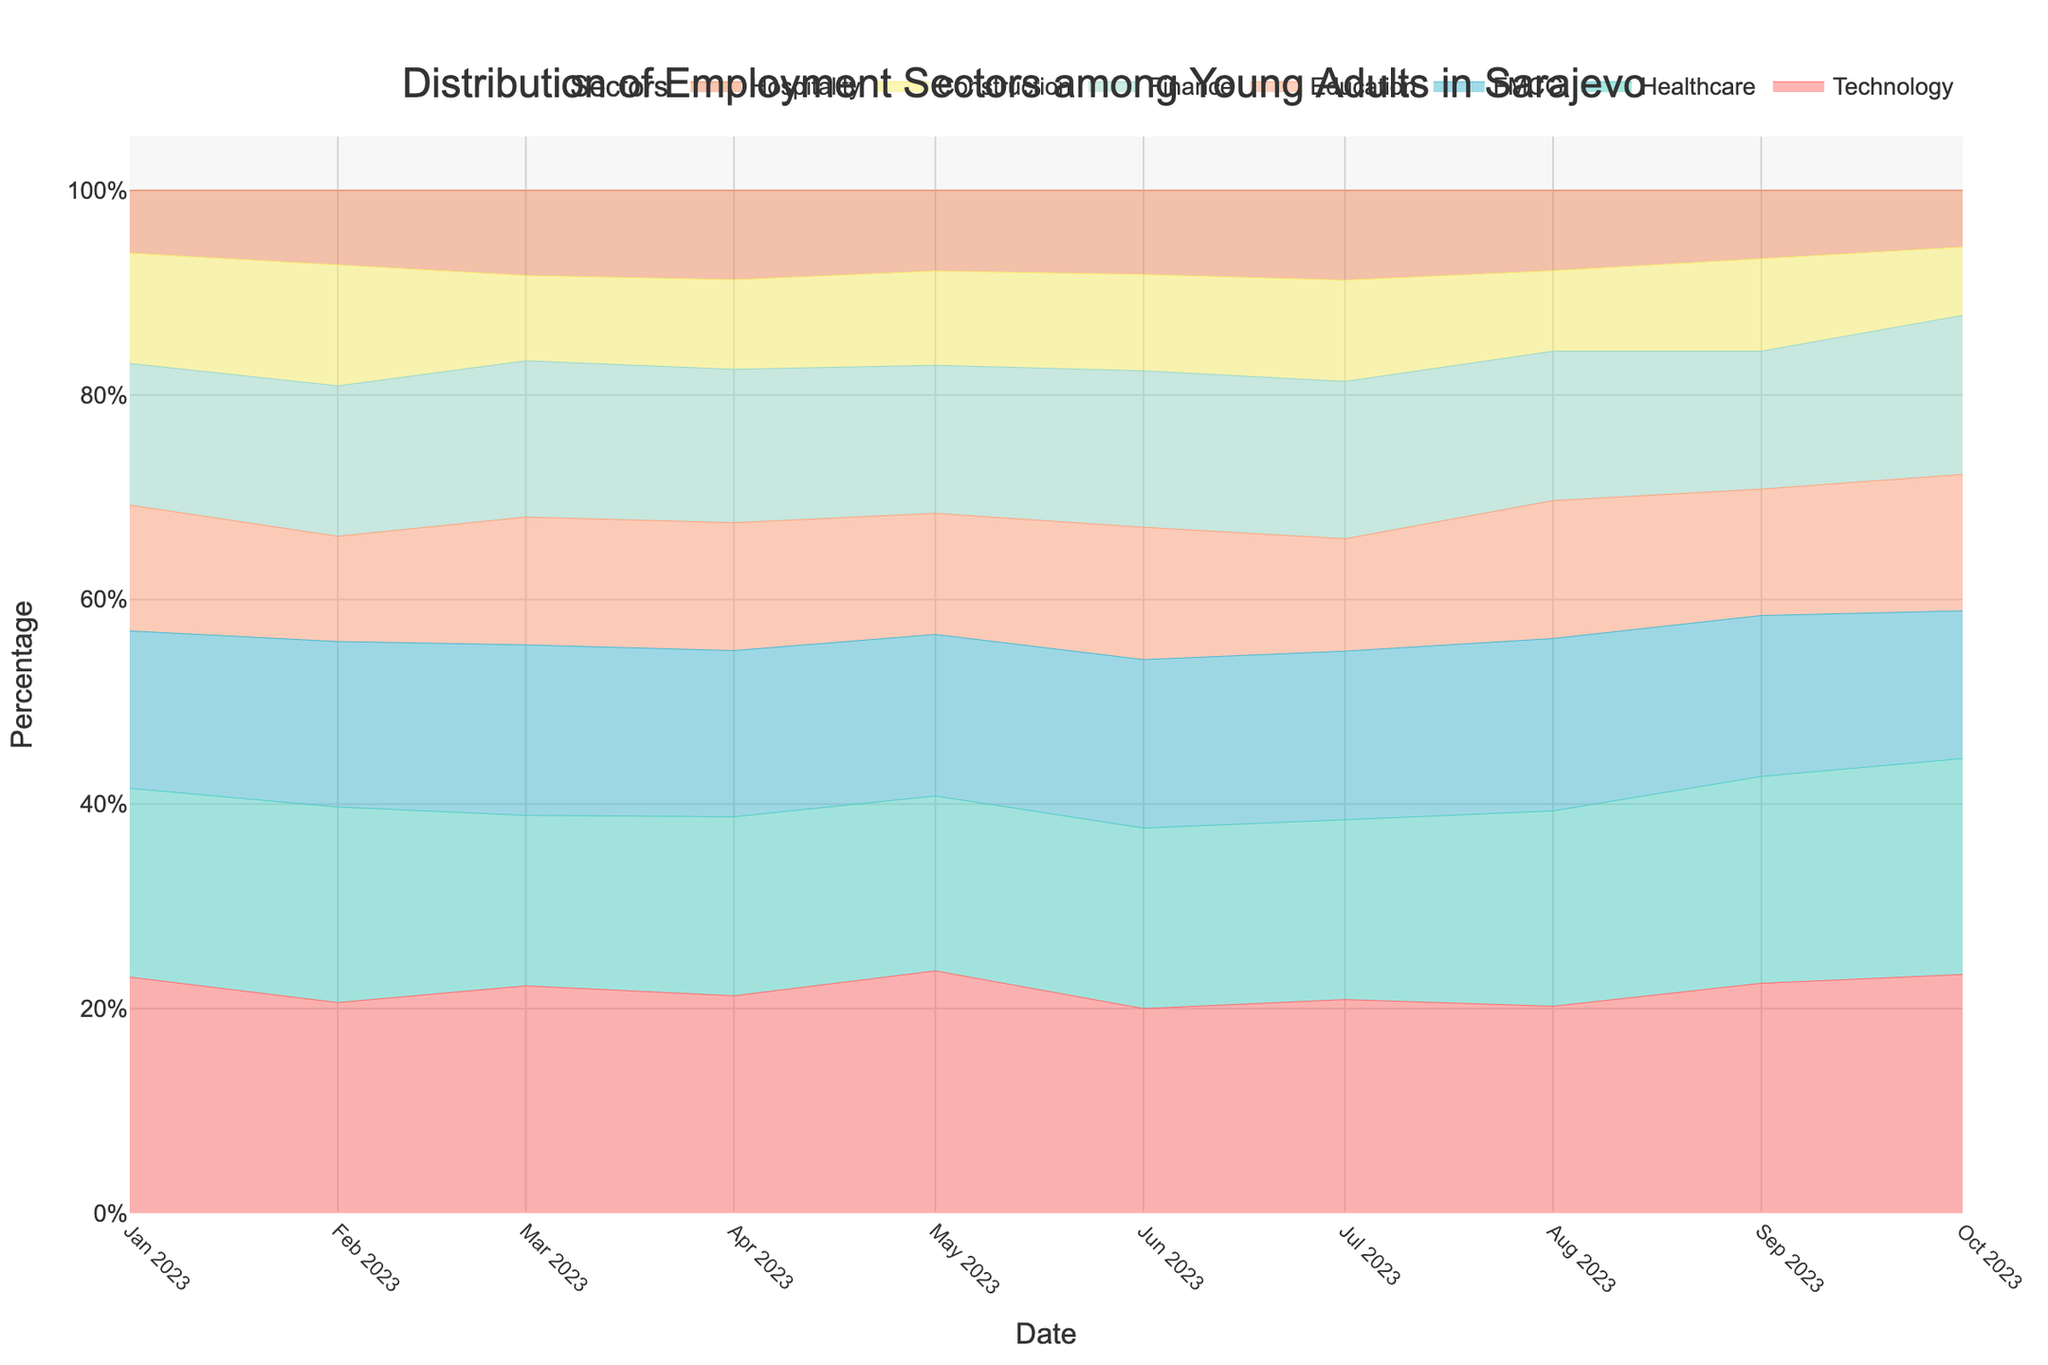What's the title of the figure? The title of the figure is found at the top and provides a summary of what the graph is about. For this figure, it is "Distribution of Employment Sectors among Young Adults in Sarajevo."
Answer: Distribution of Employment Sectors among Young Adults in Sarajevo Which sector shows the highest employment percentage in October 2023? To find the highest employment percentage in October 2023, one should look for the sector with the largest area or the highest position within the stacked stream. The Technology sector reaches the highest point in October 2023.
Answer: Technology In which month does the Hospitality sector have its highest employment percentage? To determine the peak employment for the Hospitality sector, trace the stream of the Hospitality sector (identified by its color) and find the month where this stream is at its tallest or widest. The Hospitality sector reaches its highest employment percentage in July 2023.
Answer: July 2023 Between which two months is the sharpest increase in employment for the Healthcare sector? By examining the stream for the Healthcare sector and identifying where the line experiences the steepest incline, this can be found. The sharpest increase for Healthcare is between February and March 2023.
Answer: February and March 2023 How does the employment percentage in the Construction sector change from June to October 2023? Observe the line representing the Construction sector's percentage. From June to October 2023, the employment percentage in Construction rises, reaching a higher position in the stacked area by October.
Answer: It increases During which month does the Education sector have the lowest employment percentage? Locate the stream for Education and identify the month where the line or area for Education is at its lowest. It appears that the Education sector has its lowest employment percentage in February 2023.
Answer: February 2023 By how much does the Technology sector's employment percentage change from January to October 2023? Measure the height of the Technology sector's stream at the beginning, January 2023, and compare it to the height in October 2023. The employment percentage for Technology increases from 15% to 21%, a change of 6%.
Answer: 6% Which sector has a consistently increasing trend in employment from January to October 2023? Look at the overall trend of each sector's stream. The Technology sector shows a consistently increasing trend, with its stream becoming steadily larger over time.
Answer: Technology Which two sectors show fluctuations throughout the year, without a clear increasing or decreasing trend? Identify the streams that do not show a clear upward or downward trend but rather increase and decrease throughout the months. The two sectors that show such fluctuations are Finance and FMCG.
Answer: Finance and FMCG What is the employment percentage range for the Finance sector from January to October 2023? Measure the lowest and highest points of the Finance sector's stream from January to October 2023. The employment percentage for Finance ranges from 9% to 14%.
Answer: 9% to 14% 